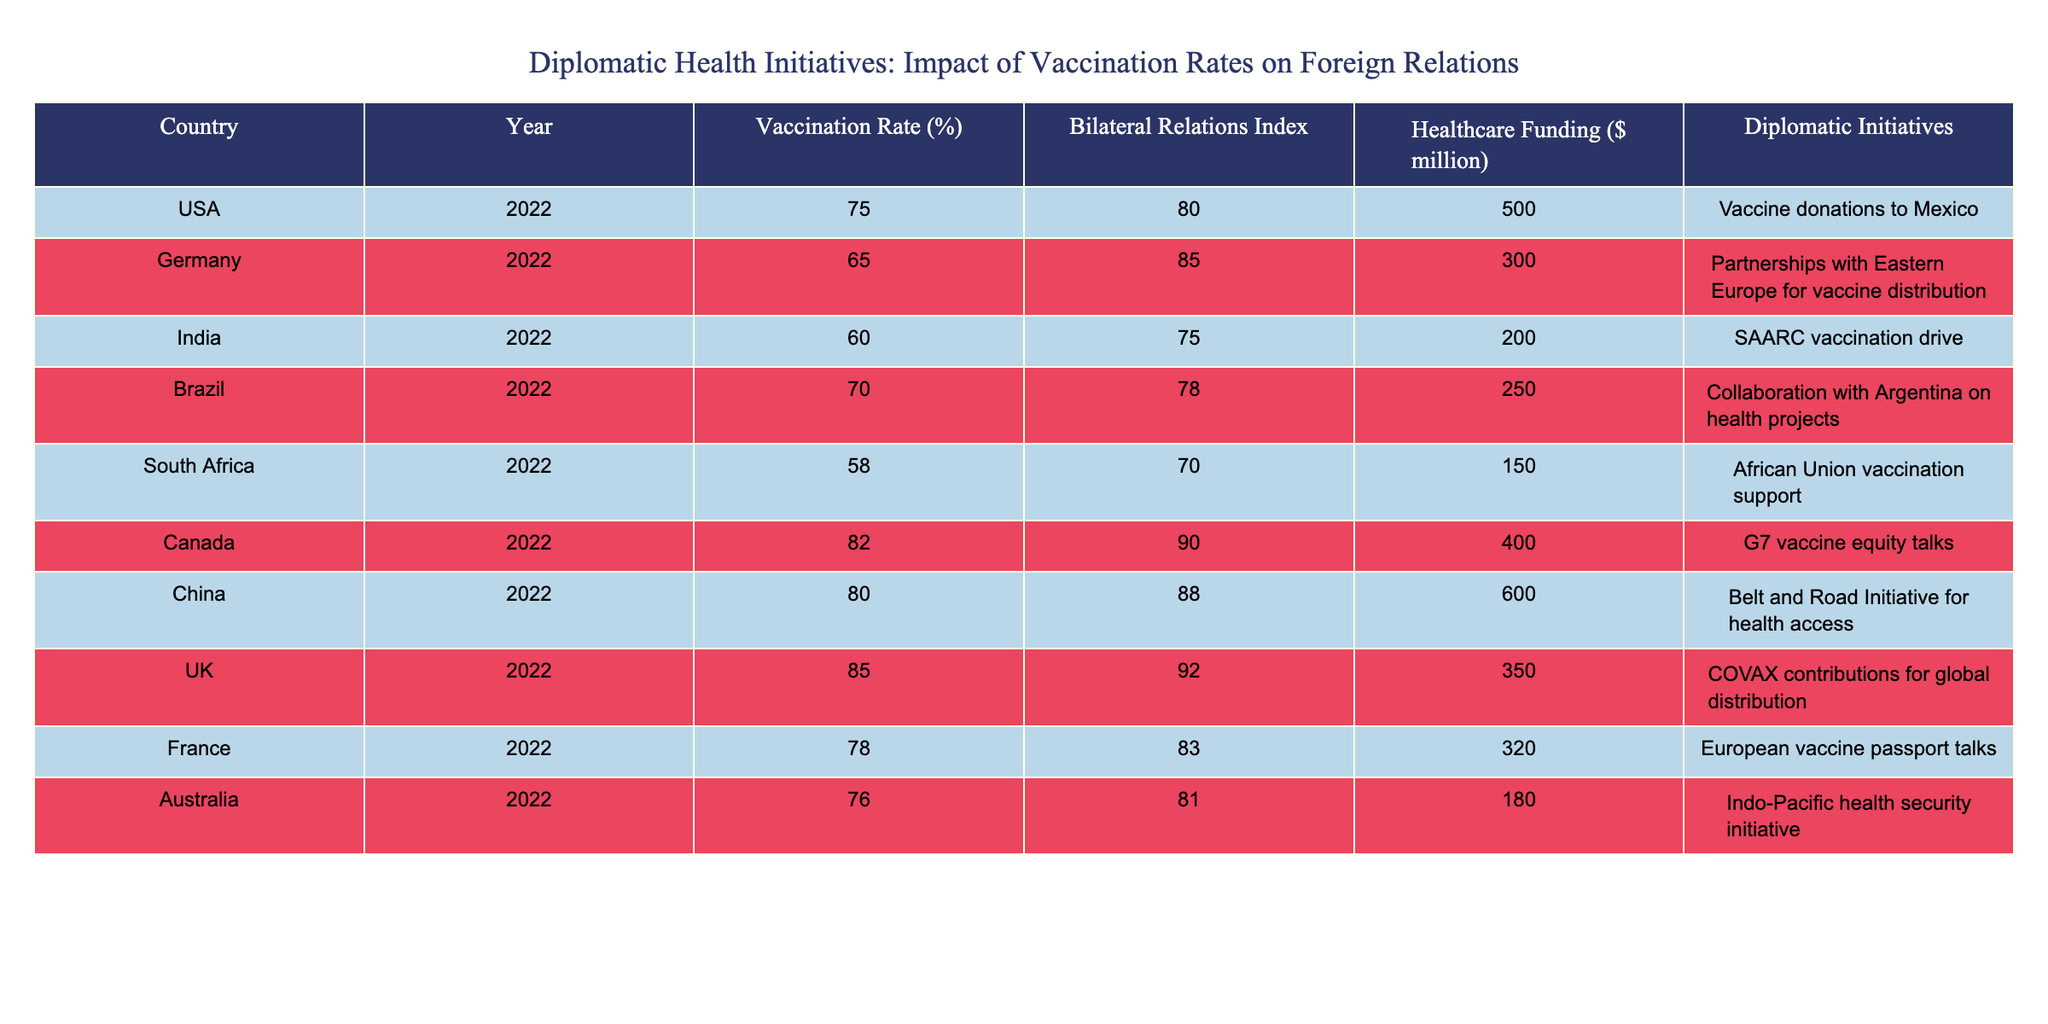What is the highest vaccination rate in the table? By examining the 'Vaccination Rate (%)' column, we can see that the UK has the highest vaccination rate at 85%.
Answer: 85 Which country has the lowest Bilateral Relations Index, and what is its value? Looking at the 'Bilateral Relations Index' column, South Africa has the lowest index at 70.
Answer: 70 What is the total healthcare funding for all countries in this table? To find the total healthcare funding, we add up all the values from the 'Healthcare Funding ($ million)' column: 500 + 300 + 200 + 250 + 150 + 400 + 600 + 350 + 320 + 180 = 2850 million dollars.
Answer: 2850 Are there more countries with a vaccination rate above 75% than those below 75%? We count the countries: USA, Canada, UK, China, Australia (above 75%) = 5, and Germany, India, Brazil, South Africa (below 75%) = 4. True, there are more countries above 75%.
Answer: Yes Which country has both a high vaccination rate and significant healthcare funding? The countries with a vaccination rate above 75% (USA, Canada, UK, and China) and their healthcare funding are: USA (500), Canada (400), UK (350), and China (600). China has the highest healthcare funding at 600 million.
Answer: China What is the average Bilateral Relations Index for the countries listed with a vaccination rate below 65%? South Africa (70) and India (75) are the only countries below 65%. The average is (70 + 75) / 2 = 72.5.
Answer: 72.5 Does Germany have a higher vaccination rate than Brazil? Germany's vaccination rate is 65%, while Brazil's is 70%. Since 70 is greater than 65, the answer is false.
Answer: No What is the difference in vaccination rates between Canada and South Africa? Canada has a vaccination rate of 82% and South Africa has 58%. The difference is calculated as 82 - 58 = 24.
Answer: 24 